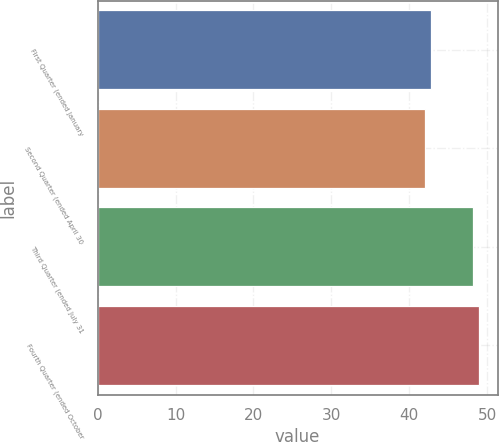Convert chart. <chart><loc_0><loc_0><loc_500><loc_500><bar_chart><fcel>First Quarter (ended January<fcel>Second Quarter (ended April 30<fcel>Third Quarter (ended July 31<fcel>Fourth Quarter (ended October<nl><fcel>42.81<fcel>42.08<fcel>48.18<fcel>48.91<nl></chart> 